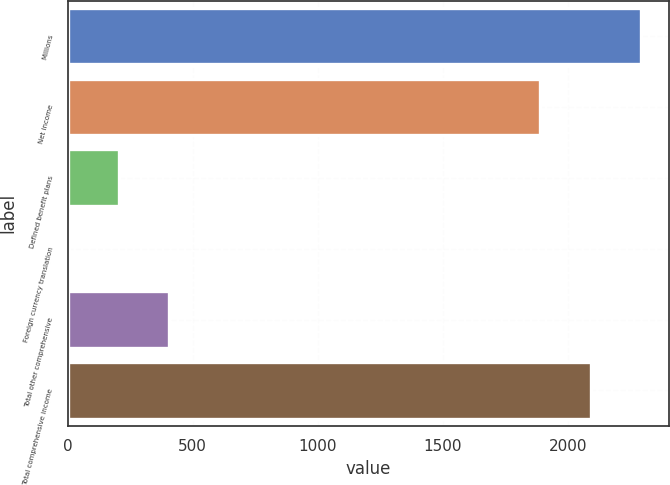Convert chart. <chart><loc_0><loc_0><loc_500><loc_500><bar_chart><fcel>Millions<fcel>Net income<fcel>Defined benefit plans<fcel>Foreign currency translation<fcel>Total other comprehensive<fcel>Total comprehensive income<nl><fcel>2290.6<fcel>1890<fcel>206.3<fcel>6<fcel>406.6<fcel>2090.3<nl></chart> 